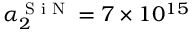<formula> <loc_0><loc_0><loc_500><loc_500>\alpha _ { 2 } ^ { S i N } = 7 \times 1 0 ^ { 1 5 }</formula> 